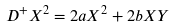<formula> <loc_0><loc_0><loc_500><loc_500>D ^ { + } X ^ { 2 } = 2 a X ^ { 2 } + 2 b X Y</formula> 